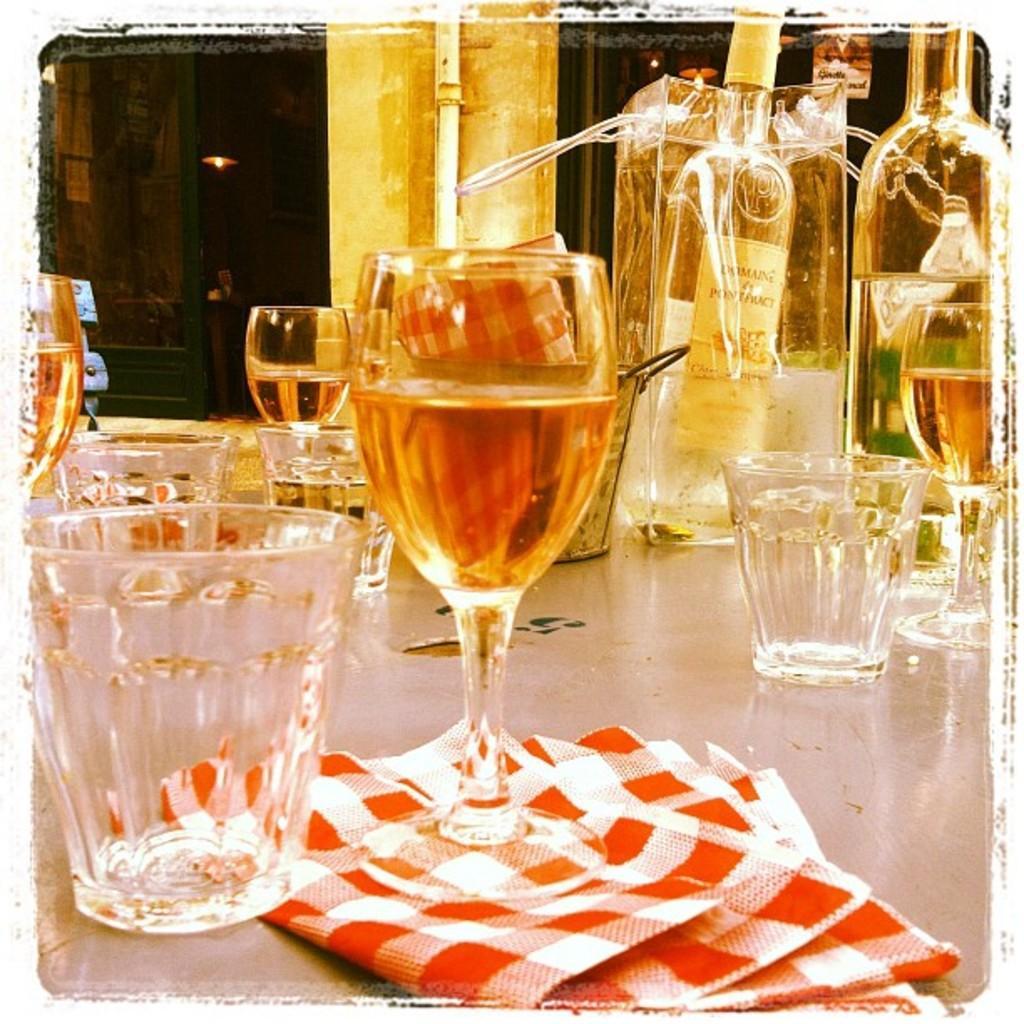Can you describe this image briefly? This is a photo. At the bottom of the image we can see the floor. On the floor we can see the bottles, glasses, cloth. At the top of the image we can see the doors, wall, pipe and lights. 